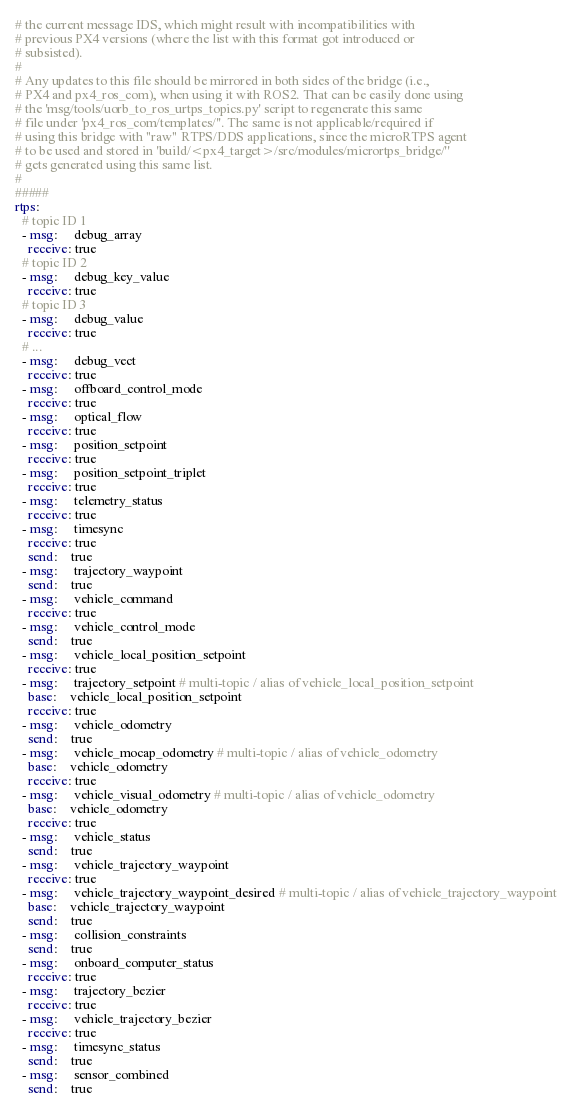<code> <loc_0><loc_0><loc_500><loc_500><_YAML_># the current message IDS, which might result with incompatibilities with
# previous PX4 versions (where the list with this format got introduced or
# subsisted).
#
# Any updates to this file should be mirrored in both sides of the bridge (i.e.,
# PX4 and px4_ros_com), when using it with ROS2. That can be easily done using
# the 'msg/tools/uorb_to_ros_urtps_topics.py' script to regenerate this same
# file under 'px4_ros_com/templates/''. The same is not applicable/required if
# using this bridge with "raw" RTPS/DDS applications, since the microRTPS agent
# to be used and stored in 'build/<px4_target>/src/modules/micrortps_bridge/''
# gets generated using this same list.
#
#####
rtps:
  # topic ID 1
  - msg:     debug_array
    receive: true
  # topic ID 2
  - msg:     debug_key_value
    receive: true
  # topic ID 3
  - msg:     debug_value
    receive: true
  # ...
  - msg:     debug_vect
    receive: true
  - msg:     offboard_control_mode
    receive: true
  - msg:     optical_flow
    receive: true
  - msg:     position_setpoint
    receive: true
  - msg:     position_setpoint_triplet
    receive: true
  - msg:     telemetry_status
    receive: true
  - msg:     timesync
    receive: true
    send:    true
  - msg:     trajectory_waypoint
    send:    true
  - msg:     vehicle_command
    receive: true
  - msg:     vehicle_control_mode
    send:    true
  - msg:     vehicle_local_position_setpoint
    receive: true
  - msg:     trajectory_setpoint # multi-topic / alias of vehicle_local_position_setpoint
    base:    vehicle_local_position_setpoint
    receive: true
  - msg:     vehicle_odometry
    send:    true
  - msg:     vehicle_mocap_odometry # multi-topic / alias of vehicle_odometry
    base:    vehicle_odometry
    receive: true
  - msg:     vehicle_visual_odometry # multi-topic / alias of vehicle_odometry
    base:    vehicle_odometry
    receive: true
  - msg:     vehicle_status
    send:    true
  - msg:     vehicle_trajectory_waypoint
    receive: true
  - msg:     vehicle_trajectory_waypoint_desired # multi-topic / alias of vehicle_trajectory_waypoint
    base:    vehicle_trajectory_waypoint
    send:    true
  - msg:     collision_constraints
    send:    true
  - msg:     onboard_computer_status
    receive: true
  - msg:     trajectory_bezier
    receive: true
  - msg:     vehicle_trajectory_bezier
    receive: true
  - msg:     timesync_status
    send:    true
  - msg:     sensor_combined
    send:    true
</code> 